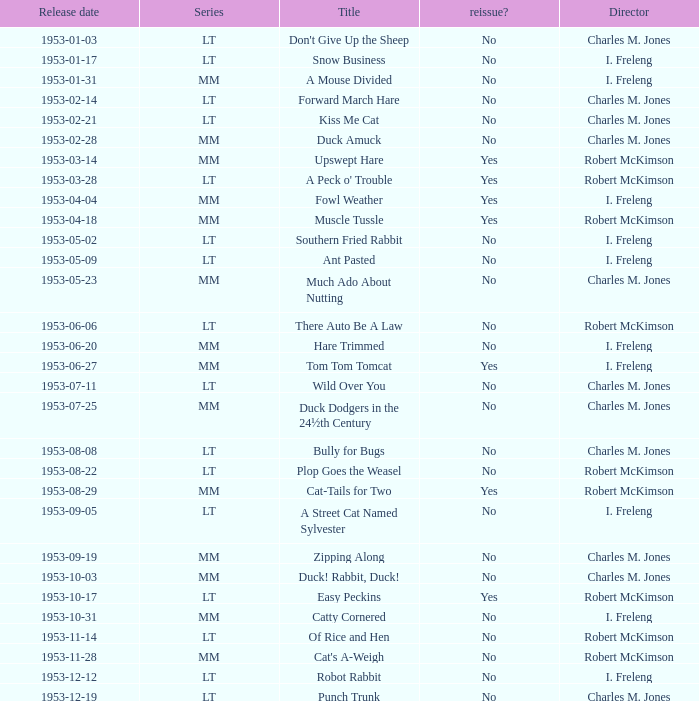What's the series of Kiss Me Cat? LT. I'm looking to parse the entire table for insights. Could you assist me with that? {'header': ['Release date', 'Series', 'Title', 'reissue?', 'Director'], 'rows': [['1953-01-03', 'LT', "Don't Give Up the Sheep", 'No', 'Charles M. Jones'], ['1953-01-17', 'LT', 'Snow Business', 'No', 'I. Freleng'], ['1953-01-31', 'MM', 'A Mouse Divided', 'No', 'I. Freleng'], ['1953-02-14', 'LT', 'Forward March Hare', 'No', 'Charles M. Jones'], ['1953-02-21', 'LT', 'Kiss Me Cat', 'No', 'Charles M. Jones'], ['1953-02-28', 'MM', 'Duck Amuck', 'No', 'Charles M. Jones'], ['1953-03-14', 'MM', 'Upswept Hare', 'Yes', 'Robert McKimson'], ['1953-03-28', 'LT', "A Peck o' Trouble", 'Yes', 'Robert McKimson'], ['1953-04-04', 'MM', 'Fowl Weather', 'Yes', 'I. Freleng'], ['1953-04-18', 'MM', 'Muscle Tussle', 'Yes', 'Robert McKimson'], ['1953-05-02', 'LT', 'Southern Fried Rabbit', 'No', 'I. Freleng'], ['1953-05-09', 'LT', 'Ant Pasted', 'No', 'I. Freleng'], ['1953-05-23', 'MM', 'Much Ado About Nutting', 'No', 'Charles M. Jones'], ['1953-06-06', 'LT', 'There Auto Be A Law', 'No', 'Robert McKimson'], ['1953-06-20', 'MM', 'Hare Trimmed', 'No', 'I. Freleng'], ['1953-06-27', 'MM', 'Tom Tom Tomcat', 'Yes', 'I. Freleng'], ['1953-07-11', 'LT', 'Wild Over You', 'No', 'Charles M. Jones'], ['1953-07-25', 'MM', 'Duck Dodgers in the 24½th Century', 'No', 'Charles M. Jones'], ['1953-08-08', 'LT', 'Bully for Bugs', 'No', 'Charles M. Jones'], ['1953-08-22', 'LT', 'Plop Goes the Weasel', 'No', 'Robert McKimson'], ['1953-08-29', 'MM', 'Cat-Tails for Two', 'Yes', 'Robert McKimson'], ['1953-09-05', 'LT', 'A Street Cat Named Sylvester', 'No', 'I. Freleng'], ['1953-09-19', 'MM', 'Zipping Along', 'No', 'Charles M. Jones'], ['1953-10-03', 'MM', 'Duck! Rabbit, Duck!', 'No', 'Charles M. Jones'], ['1953-10-17', 'LT', 'Easy Peckins', 'Yes', 'Robert McKimson'], ['1953-10-31', 'MM', 'Catty Cornered', 'No', 'I. Freleng'], ['1953-11-14', 'LT', 'Of Rice and Hen', 'No', 'Robert McKimson'], ['1953-11-28', 'MM', "Cat's A-Weigh", 'No', 'Robert McKimson'], ['1953-12-12', 'LT', 'Robot Rabbit', 'No', 'I. Freleng'], ['1953-12-19', 'LT', 'Punch Trunk', 'No', 'Charles M. Jones']]} 